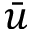<formula> <loc_0><loc_0><loc_500><loc_500>\bar { u }</formula> 